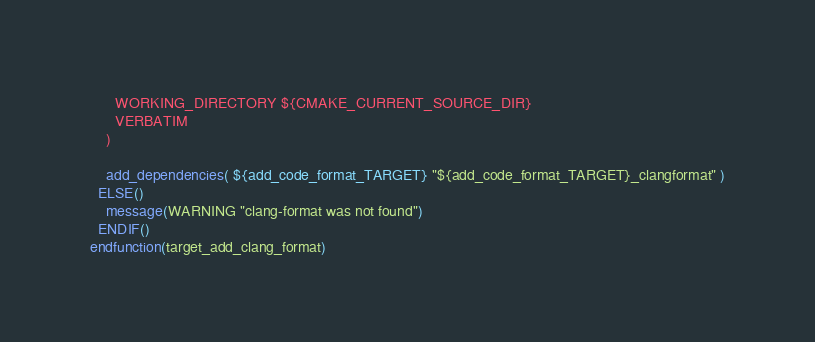<code> <loc_0><loc_0><loc_500><loc_500><_CMake_>      WORKING_DIRECTORY ${CMAKE_CURRENT_SOURCE_DIR}
      VERBATIM
    )

    add_dependencies( ${add_code_format_TARGET} "${add_code_format_TARGET}_clangformat" )
  ELSE()
    message(WARNING "clang-format was not found")
  ENDIF()
endfunction(target_add_clang_format)
</code> 